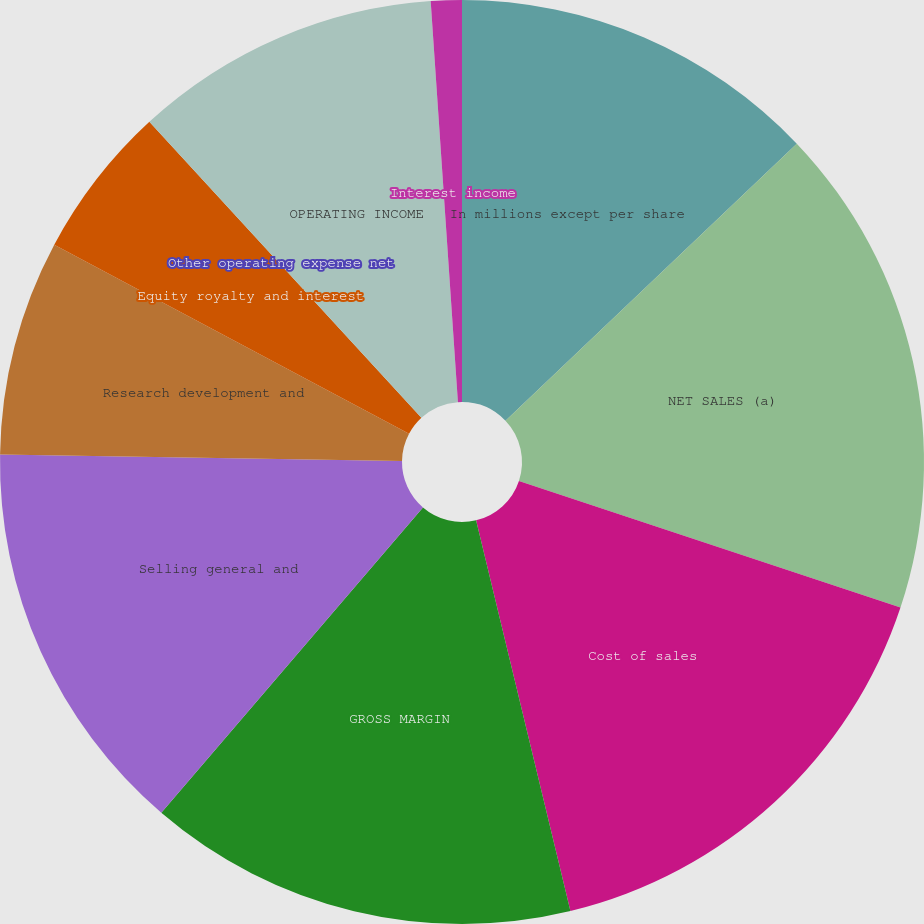Convert chart to OTSL. <chart><loc_0><loc_0><loc_500><loc_500><pie_chart><fcel>In millions except per share<fcel>NET SALES (a)<fcel>Cost of sales<fcel>GROSS MARGIN<fcel>Selling general and<fcel>Research development and<fcel>Equity royalty and interest<fcel>Other operating expense net<fcel>OPERATING INCOME<fcel>Interest income<nl><fcel>12.9%<fcel>17.2%<fcel>16.13%<fcel>15.05%<fcel>13.98%<fcel>7.53%<fcel>5.38%<fcel>0.0%<fcel>10.75%<fcel>1.08%<nl></chart> 